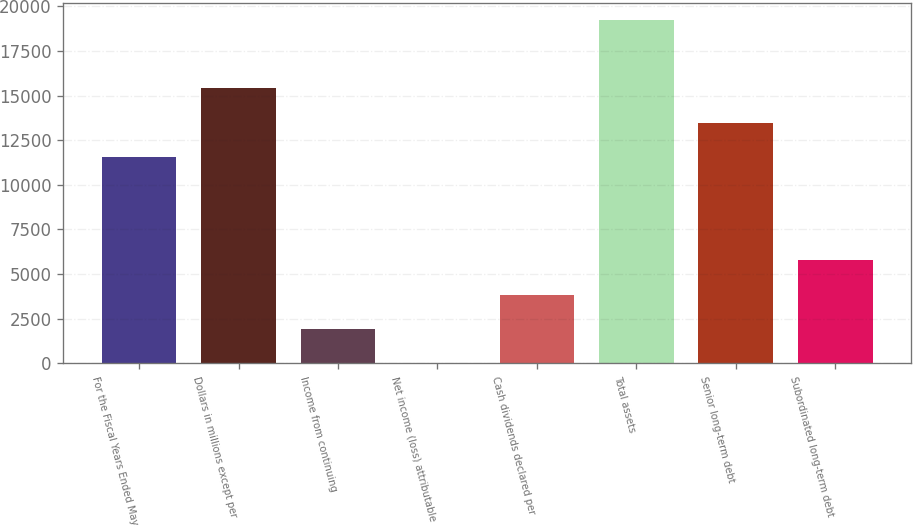Convert chart. <chart><loc_0><loc_0><loc_500><loc_500><bar_chart><fcel>For the Fiscal Years Ended May<fcel>Dollars in millions except per<fcel>Income from continuing<fcel>Net income (loss) attributable<fcel>Cash dividends declared per<fcel>Total assets<fcel>Senior long-term debt<fcel>Subordinated long-term debt<nl><fcel>11545.2<fcel>15393.4<fcel>1924.8<fcel>0.72<fcel>3848.88<fcel>19241.5<fcel>13469.3<fcel>5772.96<nl></chart> 